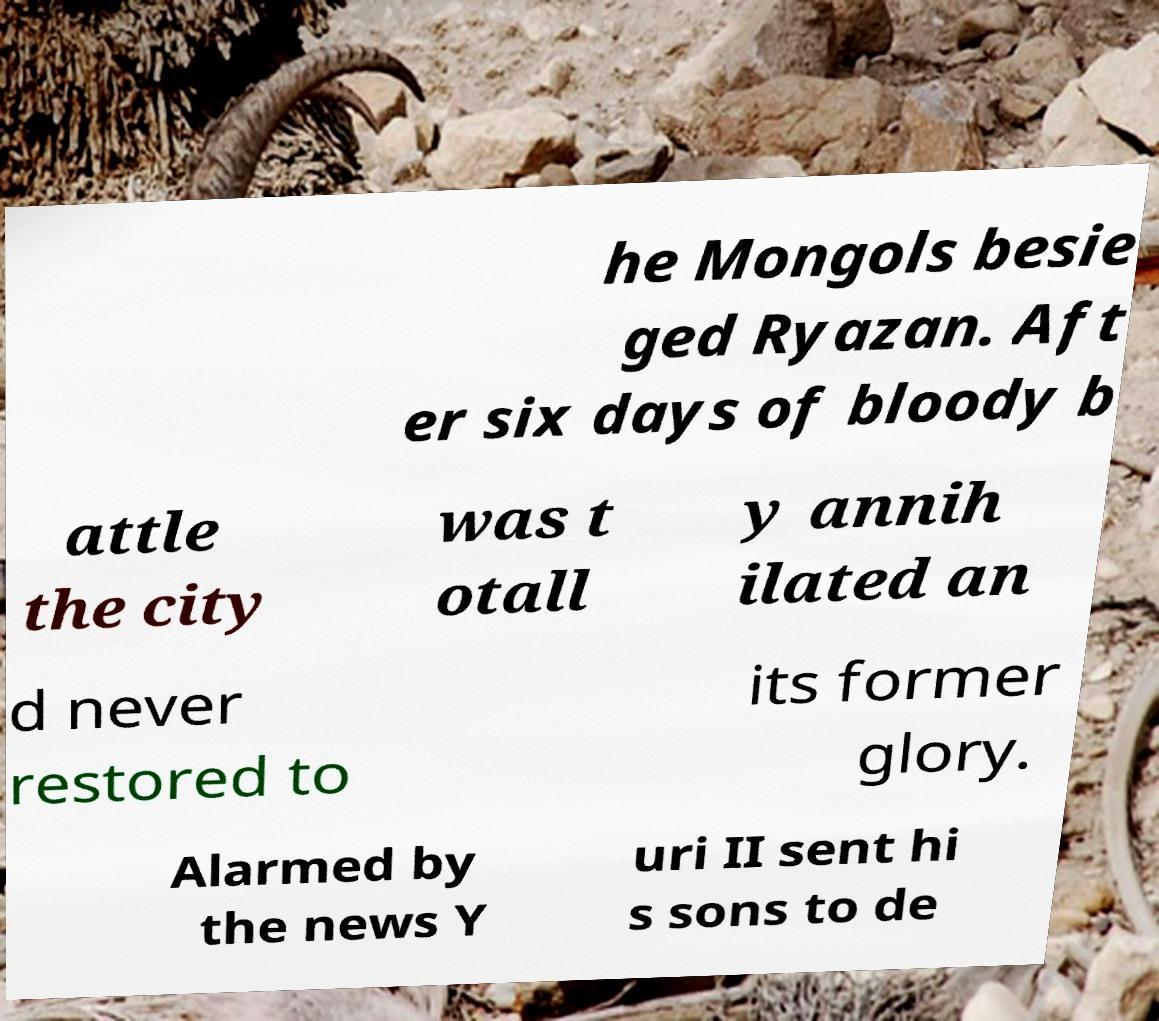What messages or text are displayed in this image? I need them in a readable, typed format. he Mongols besie ged Ryazan. Aft er six days of bloody b attle the city was t otall y annih ilated an d never restored to its former glory. Alarmed by the news Y uri II sent hi s sons to de 